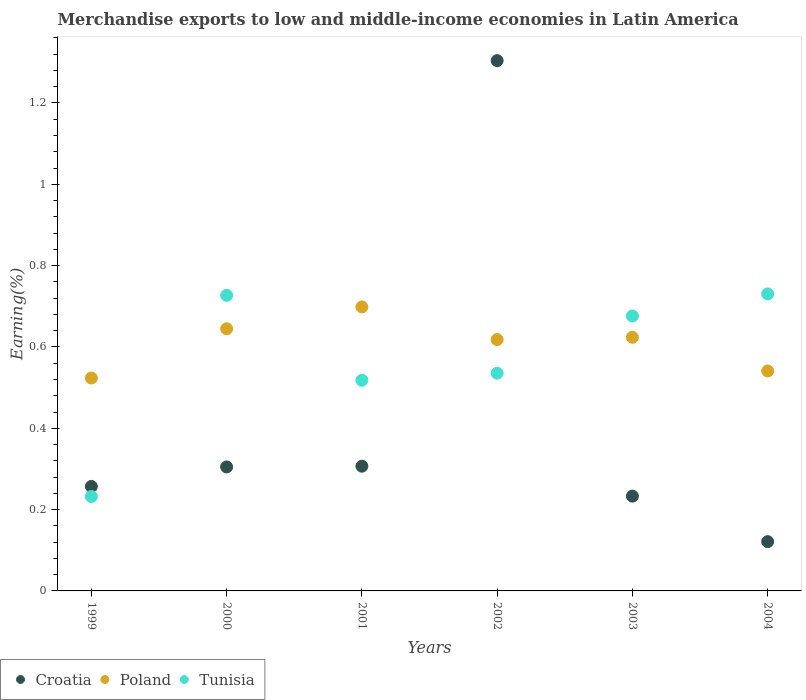How many different coloured dotlines are there?
Your answer should be compact. 3. What is the percentage of amount earned from merchandise exports in Tunisia in 2004?
Offer a terse response. 0.73. Across all years, what is the maximum percentage of amount earned from merchandise exports in Croatia?
Offer a terse response. 1.3. Across all years, what is the minimum percentage of amount earned from merchandise exports in Poland?
Your answer should be very brief. 0.52. In which year was the percentage of amount earned from merchandise exports in Tunisia maximum?
Offer a very short reply. 2004. In which year was the percentage of amount earned from merchandise exports in Croatia minimum?
Make the answer very short. 2004. What is the total percentage of amount earned from merchandise exports in Poland in the graph?
Your answer should be compact. 3.65. What is the difference between the percentage of amount earned from merchandise exports in Tunisia in 1999 and that in 2002?
Give a very brief answer. -0.3. What is the difference between the percentage of amount earned from merchandise exports in Croatia in 2000 and the percentage of amount earned from merchandise exports in Tunisia in 2001?
Keep it short and to the point. -0.21. What is the average percentage of amount earned from merchandise exports in Poland per year?
Ensure brevity in your answer.  0.61. In the year 1999, what is the difference between the percentage of amount earned from merchandise exports in Poland and percentage of amount earned from merchandise exports in Croatia?
Offer a terse response. 0.27. In how many years, is the percentage of amount earned from merchandise exports in Poland greater than 0.8 %?
Ensure brevity in your answer.  0. What is the ratio of the percentage of amount earned from merchandise exports in Croatia in 2002 to that in 2004?
Provide a succinct answer. 10.76. Is the percentage of amount earned from merchandise exports in Tunisia in 2000 less than that in 2004?
Your answer should be very brief. Yes. Is the difference between the percentage of amount earned from merchandise exports in Poland in 1999 and 2002 greater than the difference between the percentage of amount earned from merchandise exports in Croatia in 1999 and 2002?
Give a very brief answer. Yes. What is the difference between the highest and the second highest percentage of amount earned from merchandise exports in Tunisia?
Your answer should be compact. 0. What is the difference between the highest and the lowest percentage of amount earned from merchandise exports in Tunisia?
Your answer should be compact. 0.5. Is the percentage of amount earned from merchandise exports in Tunisia strictly greater than the percentage of amount earned from merchandise exports in Poland over the years?
Make the answer very short. No. Is the percentage of amount earned from merchandise exports in Croatia strictly less than the percentage of amount earned from merchandise exports in Poland over the years?
Keep it short and to the point. No. Are the values on the major ticks of Y-axis written in scientific E-notation?
Provide a short and direct response. No. Does the graph contain any zero values?
Provide a succinct answer. No. Where does the legend appear in the graph?
Your response must be concise. Bottom left. What is the title of the graph?
Keep it short and to the point. Merchandise exports to low and middle-income economies in Latin America. What is the label or title of the X-axis?
Keep it short and to the point. Years. What is the label or title of the Y-axis?
Your answer should be very brief. Earning(%). What is the Earning(%) in Croatia in 1999?
Offer a terse response. 0.26. What is the Earning(%) in Poland in 1999?
Your response must be concise. 0.52. What is the Earning(%) in Tunisia in 1999?
Provide a short and direct response. 0.23. What is the Earning(%) of Croatia in 2000?
Offer a terse response. 0.3. What is the Earning(%) in Poland in 2000?
Provide a short and direct response. 0.64. What is the Earning(%) in Tunisia in 2000?
Your response must be concise. 0.73. What is the Earning(%) of Croatia in 2001?
Your answer should be very brief. 0.31. What is the Earning(%) of Poland in 2001?
Make the answer very short. 0.7. What is the Earning(%) of Tunisia in 2001?
Your answer should be compact. 0.52. What is the Earning(%) of Croatia in 2002?
Offer a terse response. 1.3. What is the Earning(%) in Poland in 2002?
Provide a short and direct response. 0.62. What is the Earning(%) in Tunisia in 2002?
Keep it short and to the point. 0.54. What is the Earning(%) in Croatia in 2003?
Give a very brief answer. 0.23. What is the Earning(%) of Poland in 2003?
Provide a short and direct response. 0.62. What is the Earning(%) of Tunisia in 2003?
Provide a succinct answer. 0.68. What is the Earning(%) of Croatia in 2004?
Ensure brevity in your answer.  0.12. What is the Earning(%) of Poland in 2004?
Offer a terse response. 0.54. What is the Earning(%) in Tunisia in 2004?
Keep it short and to the point. 0.73. Across all years, what is the maximum Earning(%) in Croatia?
Provide a short and direct response. 1.3. Across all years, what is the maximum Earning(%) in Poland?
Keep it short and to the point. 0.7. Across all years, what is the maximum Earning(%) of Tunisia?
Ensure brevity in your answer.  0.73. Across all years, what is the minimum Earning(%) in Croatia?
Keep it short and to the point. 0.12. Across all years, what is the minimum Earning(%) in Poland?
Your answer should be very brief. 0.52. Across all years, what is the minimum Earning(%) in Tunisia?
Give a very brief answer. 0.23. What is the total Earning(%) of Croatia in the graph?
Your answer should be compact. 2.53. What is the total Earning(%) of Poland in the graph?
Keep it short and to the point. 3.65. What is the total Earning(%) in Tunisia in the graph?
Make the answer very short. 3.42. What is the difference between the Earning(%) of Croatia in 1999 and that in 2000?
Provide a short and direct response. -0.05. What is the difference between the Earning(%) in Poland in 1999 and that in 2000?
Provide a short and direct response. -0.12. What is the difference between the Earning(%) in Tunisia in 1999 and that in 2000?
Your response must be concise. -0.49. What is the difference between the Earning(%) in Croatia in 1999 and that in 2001?
Ensure brevity in your answer.  -0.05. What is the difference between the Earning(%) in Poland in 1999 and that in 2001?
Your answer should be compact. -0.17. What is the difference between the Earning(%) of Tunisia in 1999 and that in 2001?
Offer a terse response. -0.29. What is the difference between the Earning(%) in Croatia in 1999 and that in 2002?
Offer a terse response. -1.05. What is the difference between the Earning(%) of Poland in 1999 and that in 2002?
Make the answer very short. -0.09. What is the difference between the Earning(%) of Tunisia in 1999 and that in 2002?
Make the answer very short. -0.3. What is the difference between the Earning(%) in Croatia in 1999 and that in 2003?
Your response must be concise. 0.02. What is the difference between the Earning(%) of Poland in 1999 and that in 2003?
Ensure brevity in your answer.  -0.1. What is the difference between the Earning(%) in Tunisia in 1999 and that in 2003?
Make the answer very short. -0.44. What is the difference between the Earning(%) in Croatia in 1999 and that in 2004?
Ensure brevity in your answer.  0.14. What is the difference between the Earning(%) in Poland in 1999 and that in 2004?
Your answer should be very brief. -0.02. What is the difference between the Earning(%) in Tunisia in 1999 and that in 2004?
Give a very brief answer. -0.5. What is the difference between the Earning(%) in Croatia in 2000 and that in 2001?
Keep it short and to the point. -0. What is the difference between the Earning(%) of Poland in 2000 and that in 2001?
Offer a very short reply. -0.05. What is the difference between the Earning(%) in Tunisia in 2000 and that in 2001?
Make the answer very short. 0.21. What is the difference between the Earning(%) of Croatia in 2000 and that in 2002?
Make the answer very short. -1. What is the difference between the Earning(%) in Poland in 2000 and that in 2002?
Give a very brief answer. 0.03. What is the difference between the Earning(%) of Tunisia in 2000 and that in 2002?
Make the answer very short. 0.19. What is the difference between the Earning(%) of Croatia in 2000 and that in 2003?
Offer a terse response. 0.07. What is the difference between the Earning(%) in Poland in 2000 and that in 2003?
Offer a very short reply. 0.02. What is the difference between the Earning(%) in Tunisia in 2000 and that in 2003?
Keep it short and to the point. 0.05. What is the difference between the Earning(%) in Croatia in 2000 and that in 2004?
Your answer should be very brief. 0.18. What is the difference between the Earning(%) in Poland in 2000 and that in 2004?
Make the answer very short. 0.1. What is the difference between the Earning(%) in Tunisia in 2000 and that in 2004?
Your answer should be compact. -0. What is the difference between the Earning(%) of Croatia in 2001 and that in 2002?
Ensure brevity in your answer.  -1. What is the difference between the Earning(%) of Poland in 2001 and that in 2002?
Your response must be concise. 0.08. What is the difference between the Earning(%) of Tunisia in 2001 and that in 2002?
Give a very brief answer. -0.02. What is the difference between the Earning(%) in Croatia in 2001 and that in 2003?
Your answer should be compact. 0.07. What is the difference between the Earning(%) in Poland in 2001 and that in 2003?
Provide a short and direct response. 0.07. What is the difference between the Earning(%) in Tunisia in 2001 and that in 2003?
Your answer should be very brief. -0.16. What is the difference between the Earning(%) of Croatia in 2001 and that in 2004?
Offer a terse response. 0.19. What is the difference between the Earning(%) of Poland in 2001 and that in 2004?
Provide a short and direct response. 0.16. What is the difference between the Earning(%) of Tunisia in 2001 and that in 2004?
Provide a succinct answer. -0.21. What is the difference between the Earning(%) in Croatia in 2002 and that in 2003?
Offer a very short reply. 1.07. What is the difference between the Earning(%) in Poland in 2002 and that in 2003?
Keep it short and to the point. -0.01. What is the difference between the Earning(%) of Tunisia in 2002 and that in 2003?
Your answer should be compact. -0.14. What is the difference between the Earning(%) in Croatia in 2002 and that in 2004?
Keep it short and to the point. 1.18. What is the difference between the Earning(%) of Poland in 2002 and that in 2004?
Offer a terse response. 0.08. What is the difference between the Earning(%) in Tunisia in 2002 and that in 2004?
Ensure brevity in your answer.  -0.2. What is the difference between the Earning(%) in Croatia in 2003 and that in 2004?
Make the answer very short. 0.11. What is the difference between the Earning(%) in Poland in 2003 and that in 2004?
Give a very brief answer. 0.08. What is the difference between the Earning(%) of Tunisia in 2003 and that in 2004?
Give a very brief answer. -0.05. What is the difference between the Earning(%) of Croatia in 1999 and the Earning(%) of Poland in 2000?
Ensure brevity in your answer.  -0.39. What is the difference between the Earning(%) in Croatia in 1999 and the Earning(%) in Tunisia in 2000?
Ensure brevity in your answer.  -0.47. What is the difference between the Earning(%) in Poland in 1999 and the Earning(%) in Tunisia in 2000?
Provide a succinct answer. -0.2. What is the difference between the Earning(%) in Croatia in 1999 and the Earning(%) in Poland in 2001?
Your answer should be compact. -0.44. What is the difference between the Earning(%) of Croatia in 1999 and the Earning(%) of Tunisia in 2001?
Make the answer very short. -0.26. What is the difference between the Earning(%) in Poland in 1999 and the Earning(%) in Tunisia in 2001?
Make the answer very short. 0.01. What is the difference between the Earning(%) in Croatia in 1999 and the Earning(%) in Poland in 2002?
Your response must be concise. -0.36. What is the difference between the Earning(%) of Croatia in 1999 and the Earning(%) of Tunisia in 2002?
Give a very brief answer. -0.28. What is the difference between the Earning(%) of Poland in 1999 and the Earning(%) of Tunisia in 2002?
Offer a terse response. -0.01. What is the difference between the Earning(%) of Croatia in 1999 and the Earning(%) of Poland in 2003?
Offer a very short reply. -0.37. What is the difference between the Earning(%) in Croatia in 1999 and the Earning(%) in Tunisia in 2003?
Your answer should be compact. -0.42. What is the difference between the Earning(%) in Poland in 1999 and the Earning(%) in Tunisia in 2003?
Your answer should be very brief. -0.15. What is the difference between the Earning(%) of Croatia in 1999 and the Earning(%) of Poland in 2004?
Keep it short and to the point. -0.28. What is the difference between the Earning(%) of Croatia in 1999 and the Earning(%) of Tunisia in 2004?
Ensure brevity in your answer.  -0.47. What is the difference between the Earning(%) in Poland in 1999 and the Earning(%) in Tunisia in 2004?
Your answer should be very brief. -0.21. What is the difference between the Earning(%) in Croatia in 2000 and the Earning(%) in Poland in 2001?
Your response must be concise. -0.39. What is the difference between the Earning(%) of Croatia in 2000 and the Earning(%) of Tunisia in 2001?
Provide a short and direct response. -0.21. What is the difference between the Earning(%) in Poland in 2000 and the Earning(%) in Tunisia in 2001?
Keep it short and to the point. 0.13. What is the difference between the Earning(%) in Croatia in 2000 and the Earning(%) in Poland in 2002?
Offer a very short reply. -0.31. What is the difference between the Earning(%) of Croatia in 2000 and the Earning(%) of Tunisia in 2002?
Your response must be concise. -0.23. What is the difference between the Earning(%) in Poland in 2000 and the Earning(%) in Tunisia in 2002?
Your answer should be very brief. 0.11. What is the difference between the Earning(%) in Croatia in 2000 and the Earning(%) in Poland in 2003?
Provide a short and direct response. -0.32. What is the difference between the Earning(%) of Croatia in 2000 and the Earning(%) of Tunisia in 2003?
Offer a very short reply. -0.37. What is the difference between the Earning(%) in Poland in 2000 and the Earning(%) in Tunisia in 2003?
Make the answer very short. -0.03. What is the difference between the Earning(%) in Croatia in 2000 and the Earning(%) in Poland in 2004?
Offer a very short reply. -0.24. What is the difference between the Earning(%) of Croatia in 2000 and the Earning(%) of Tunisia in 2004?
Offer a terse response. -0.43. What is the difference between the Earning(%) of Poland in 2000 and the Earning(%) of Tunisia in 2004?
Offer a very short reply. -0.09. What is the difference between the Earning(%) in Croatia in 2001 and the Earning(%) in Poland in 2002?
Give a very brief answer. -0.31. What is the difference between the Earning(%) of Croatia in 2001 and the Earning(%) of Tunisia in 2002?
Provide a short and direct response. -0.23. What is the difference between the Earning(%) of Poland in 2001 and the Earning(%) of Tunisia in 2002?
Offer a terse response. 0.16. What is the difference between the Earning(%) of Croatia in 2001 and the Earning(%) of Poland in 2003?
Make the answer very short. -0.32. What is the difference between the Earning(%) of Croatia in 2001 and the Earning(%) of Tunisia in 2003?
Provide a succinct answer. -0.37. What is the difference between the Earning(%) in Poland in 2001 and the Earning(%) in Tunisia in 2003?
Give a very brief answer. 0.02. What is the difference between the Earning(%) of Croatia in 2001 and the Earning(%) of Poland in 2004?
Your response must be concise. -0.23. What is the difference between the Earning(%) of Croatia in 2001 and the Earning(%) of Tunisia in 2004?
Keep it short and to the point. -0.42. What is the difference between the Earning(%) in Poland in 2001 and the Earning(%) in Tunisia in 2004?
Offer a terse response. -0.03. What is the difference between the Earning(%) in Croatia in 2002 and the Earning(%) in Poland in 2003?
Give a very brief answer. 0.68. What is the difference between the Earning(%) of Croatia in 2002 and the Earning(%) of Tunisia in 2003?
Keep it short and to the point. 0.63. What is the difference between the Earning(%) of Poland in 2002 and the Earning(%) of Tunisia in 2003?
Your answer should be compact. -0.06. What is the difference between the Earning(%) in Croatia in 2002 and the Earning(%) in Poland in 2004?
Your answer should be compact. 0.76. What is the difference between the Earning(%) in Croatia in 2002 and the Earning(%) in Tunisia in 2004?
Your response must be concise. 0.57. What is the difference between the Earning(%) in Poland in 2002 and the Earning(%) in Tunisia in 2004?
Ensure brevity in your answer.  -0.11. What is the difference between the Earning(%) of Croatia in 2003 and the Earning(%) of Poland in 2004?
Your answer should be very brief. -0.31. What is the difference between the Earning(%) of Croatia in 2003 and the Earning(%) of Tunisia in 2004?
Your response must be concise. -0.5. What is the difference between the Earning(%) of Poland in 2003 and the Earning(%) of Tunisia in 2004?
Offer a very short reply. -0.11. What is the average Earning(%) of Croatia per year?
Ensure brevity in your answer.  0.42. What is the average Earning(%) in Poland per year?
Your answer should be very brief. 0.61. What is the average Earning(%) of Tunisia per year?
Your answer should be very brief. 0.57. In the year 1999, what is the difference between the Earning(%) in Croatia and Earning(%) in Poland?
Offer a terse response. -0.27. In the year 1999, what is the difference between the Earning(%) in Croatia and Earning(%) in Tunisia?
Offer a very short reply. 0.02. In the year 1999, what is the difference between the Earning(%) in Poland and Earning(%) in Tunisia?
Provide a short and direct response. 0.29. In the year 2000, what is the difference between the Earning(%) in Croatia and Earning(%) in Poland?
Ensure brevity in your answer.  -0.34. In the year 2000, what is the difference between the Earning(%) in Croatia and Earning(%) in Tunisia?
Your response must be concise. -0.42. In the year 2000, what is the difference between the Earning(%) in Poland and Earning(%) in Tunisia?
Ensure brevity in your answer.  -0.08. In the year 2001, what is the difference between the Earning(%) of Croatia and Earning(%) of Poland?
Ensure brevity in your answer.  -0.39. In the year 2001, what is the difference between the Earning(%) of Croatia and Earning(%) of Tunisia?
Keep it short and to the point. -0.21. In the year 2001, what is the difference between the Earning(%) in Poland and Earning(%) in Tunisia?
Offer a very short reply. 0.18. In the year 2002, what is the difference between the Earning(%) of Croatia and Earning(%) of Poland?
Your answer should be very brief. 0.69. In the year 2002, what is the difference between the Earning(%) of Croatia and Earning(%) of Tunisia?
Your answer should be very brief. 0.77. In the year 2002, what is the difference between the Earning(%) of Poland and Earning(%) of Tunisia?
Provide a succinct answer. 0.08. In the year 2003, what is the difference between the Earning(%) of Croatia and Earning(%) of Poland?
Provide a short and direct response. -0.39. In the year 2003, what is the difference between the Earning(%) in Croatia and Earning(%) in Tunisia?
Give a very brief answer. -0.44. In the year 2003, what is the difference between the Earning(%) of Poland and Earning(%) of Tunisia?
Offer a very short reply. -0.05. In the year 2004, what is the difference between the Earning(%) in Croatia and Earning(%) in Poland?
Keep it short and to the point. -0.42. In the year 2004, what is the difference between the Earning(%) in Croatia and Earning(%) in Tunisia?
Provide a short and direct response. -0.61. In the year 2004, what is the difference between the Earning(%) of Poland and Earning(%) of Tunisia?
Offer a very short reply. -0.19. What is the ratio of the Earning(%) of Croatia in 1999 to that in 2000?
Make the answer very short. 0.84. What is the ratio of the Earning(%) in Poland in 1999 to that in 2000?
Your response must be concise. 0.81. What is the ratio of the Earning(%) in Tunisia in 1999 to that in 2000?
Keep it short and to the point. 0.32. What is the ratio of the Earning(%) of Croatia in 1999 to that in 2001?
Keep it short and to the point. 0.84. What is the ratio of the Earning(%) of Poland in 1999 to that in 2001?
Offer a terse response. 0.75. What is the ratio of the Earning(%) of Tunisia in 1999 to that in 2001?
Your answer should be very brief. 0.45. What is the ratio of the Earning(%) of Croatia in 1999 to that in 2002?
Provide a short and direct response. 0.2. What is the ratio of the Earning(%) of Poland in 1999 to that in 2002?
Keep it short and to the point. 0.85. What is the ratio of the Earning(%) of Tunisia in 1999 to that in 2002?
Offer a very short reply. 0.43. What is the ratio of the Earning(%) of Croatia in 1999 to that in 2003?
Offer a very short reply. 1.1. What is the ratio of the Earning(%) in Poland in 1999 to that in 2003?
Your response must be concise. 0.84. What is the ratio of the Earning(%) of Tunisia in 1999 to that in 2003?
Make the answer very short. 0.34. What is the ratio of the Earning(%) of Croatia in 1999 to that in 2004?
Offer a very short reply. 2.12. What is the ratio of the Earning(%) in Poland in 1999 to that in 2004?
Ensure brevity in your answer.  0.97. What is the ratio of the Earning(%) of Tunisia in 1999 to that in 2004?
Offer a very short reply. 0.32. What is the ratio of the Earning(%) in Croatia in 2000 to that in 2001?
Your answer should be compact. 0.99. What is the ratio of the Earning(%) in Poland in 2000 to that in 2001?
Offer a terse response. 0.92. What is the ratio of the Earning(%) of Tunisia in 2000 to that in 2001?
Keep it short and to the point. 1.4. What is the ratio of the Earning(%) of Croatia in 2000 to that in 2002?
Ensure brevity in your answer.  0.23. What is the ratio of the Earning(%) of Poland in 2000 to that in 2002?
Ensure brevity in your answer.  1.04. What is the ratio of the Earning(%) in Tunisia in 2000 to that in 2002?
Give a very brief answer. 1.36. What is the ratio of the Earning(%) in Croatia in 2000 to that in 2003?
Provide a short and direct response. 1.31. What is the ratio of the Earning(%) of Poland in 2000 to that in 2003?
Offer a very short reply. 1.03. What is the ratio of the Earning(%) in Tunisia in 2000 to that in 2003?
Offer a very short reply. 1.08. What is the ratio of the Earning(%) of Croatia in 2000 to that in 2004?
Your answer should be very brief. 2.52. What is the ratio of the Earning(%) of Poland in 2000 to that in 2004?
Give a very brief answer. 1.19. What is the ratio of the Earning(%) in Tunisia in 2000 to that in 2004?
Your answer should be compact. 1. What is the ratio of the Earning(%) in Croatia in 2001 to that in 2002?
Provide a succinct answer. 0.24. What is the ratio of the Earning(%) in Poland in 2001 to that in 2002?
Your response must be concise. 1.13. What is the ratio of the Earning(%) of Tunisia in 2001 to that in 2002?
Give a very brief answer. 0.97. What is the ratio of the Earning(%) in Croatia in 2001 to that in 2003?
Give a very brief answer. 1.32. What is the ratio of the Earning(%) in Poland in 2001 to that in 2003?
Provide a short and direct response. 1.12. What is the ratio of the Earning(%) of Tunisia in 2001 to that in 2003?
Offer a very short reply. 0.77. What is the ratio of the Earning(%) in Croatia in 2001 to that in 2004?
Provide a succinct answer. 2.53. What is the ratio of the Earning(%) of Poland in 2001 to that in 2004?
Give a very brief answer. 1.29. What is the ratio of the Earning(%) in Tunisia in 2001 to that in 2004?
Provide a short and direct response. 0.71. What is the ratio of the Earning(%) in Croatia in 2002 to that in 2003?
Your response must be concise. 5.59. What is the ratio of the Earning(%) of Tunisia in 2002 to that in 2003?
Your answer should be very brief. 0.79. What is the ratio of the Earning(%) in Croatia in 2002 to that in 2004?
Your answer should be compact. 10.76. What is the ratio of the Earning(%) in Poland in 2002 to that in 2004?
Make the answer very short. 1.14. What is the ratio of the Earning(%) of Tunisia in 2002 to that in 2004?
Give a very brief answer. 0.73. What is the ratio of the Earning(%) of Croatia in 2003 to that in 2004?
Provide a succinct answer. 1.92. What is the ratio of the Earning(%) of Poland in 2003 to that in 2004?
Offer a very short reply. 1.15. What is the ratio of the Earning(%) in Tunisia in 2003 to that in 2004?
Make the answer very short. 0.93. What is the difference between the highest and the second highest Earning(%) of Poland?
Ensure brevity in your answer.  0.05. What is the difference between the highest and the second highest Earning(%) of Tunisia?
Make the answer very short. 0. What is the difference between the highest and the lowest Earning(%) of Croatia?
Your answer should be very brief. 1.18. What is the difference between the highest and the lowest Earning(%) of Poland?
Keep it short and to the point. 0.17. What is the difference between the highest and the lowest Earning(%) of Tunisia?
Your answer should be compact. 0.5. 